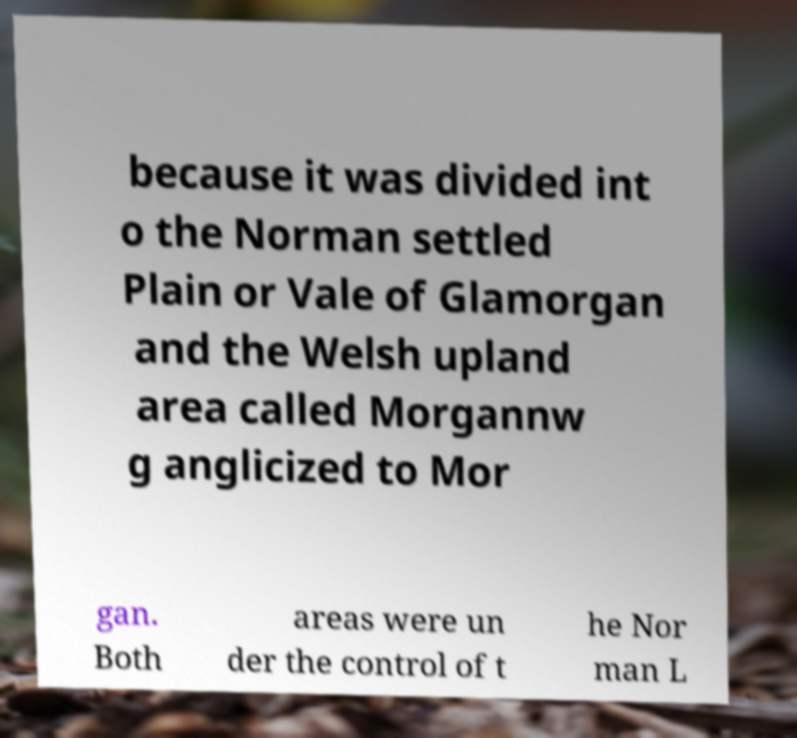Could you assist in decoding the text presented in this image and type it out clearly? because it was divided int o the Norman settled Plain or Vale of Glamorgan and the Welsh upland area called Morgannw g anglicized to Mor gan. Both areas were un der the control of t he Nor man L 